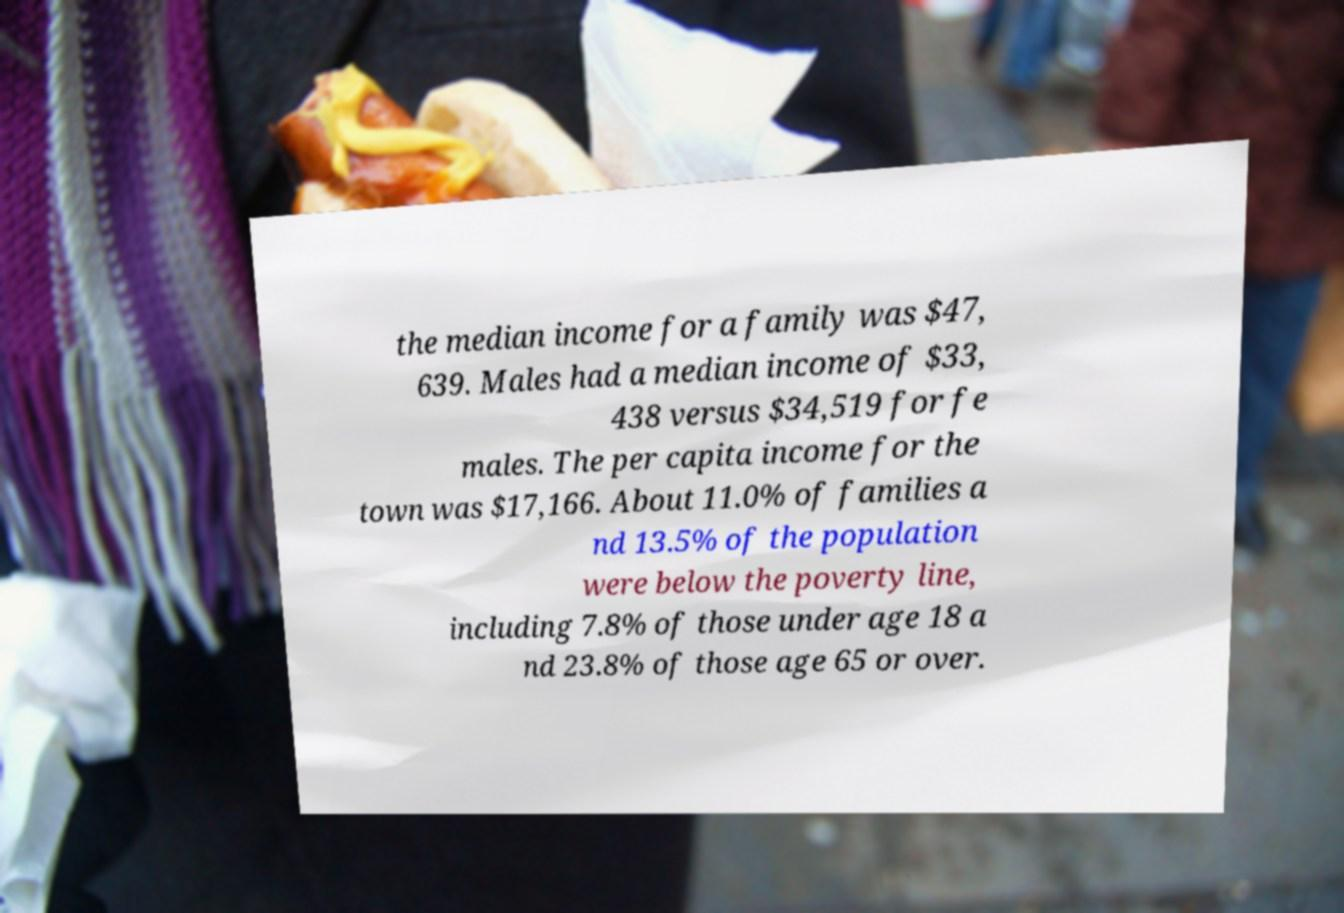I need the written content from this picture converted into text. Can you do that? the median income for a family was $47, 639. Males had a median income of $33, 438 versus $34,519 for fe males. The per capita income for the town was $17,166. About 11.0% of families a nd 13.5% of the population were below the poverty line, including 7.8% of those under age 18 a nd 23.8% of those age 65 or over. 